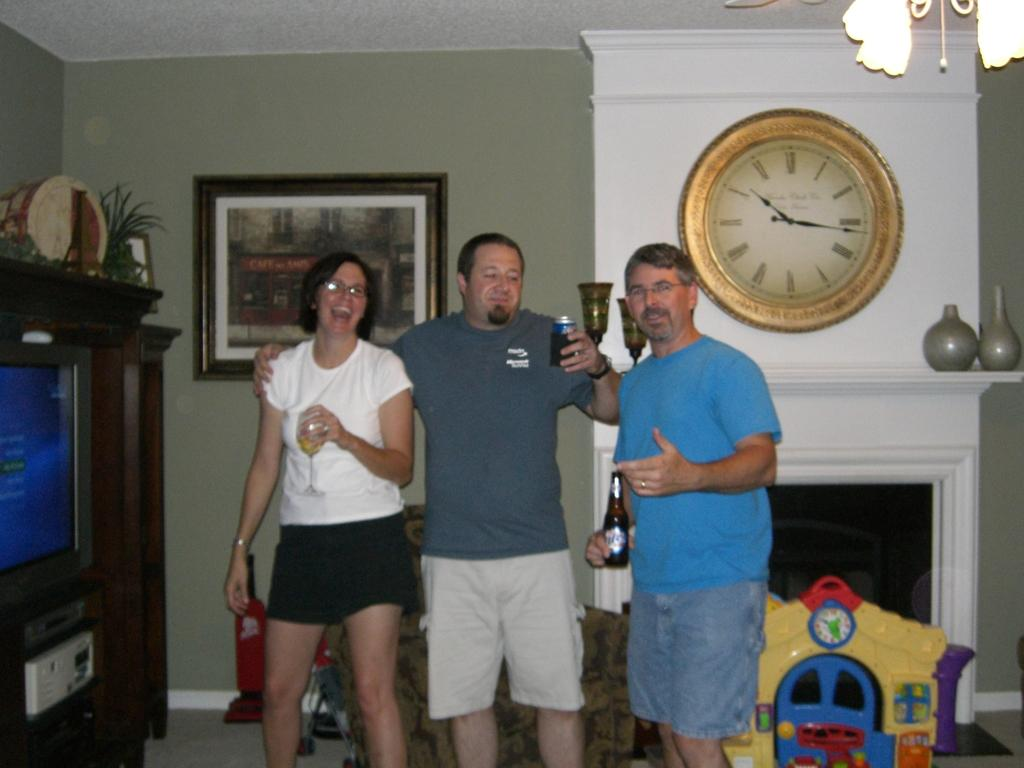<image>
Relay a brief, clear account of the picture shown. Three people stand in front of a fireplace with a clock that shows the time as 10:16 